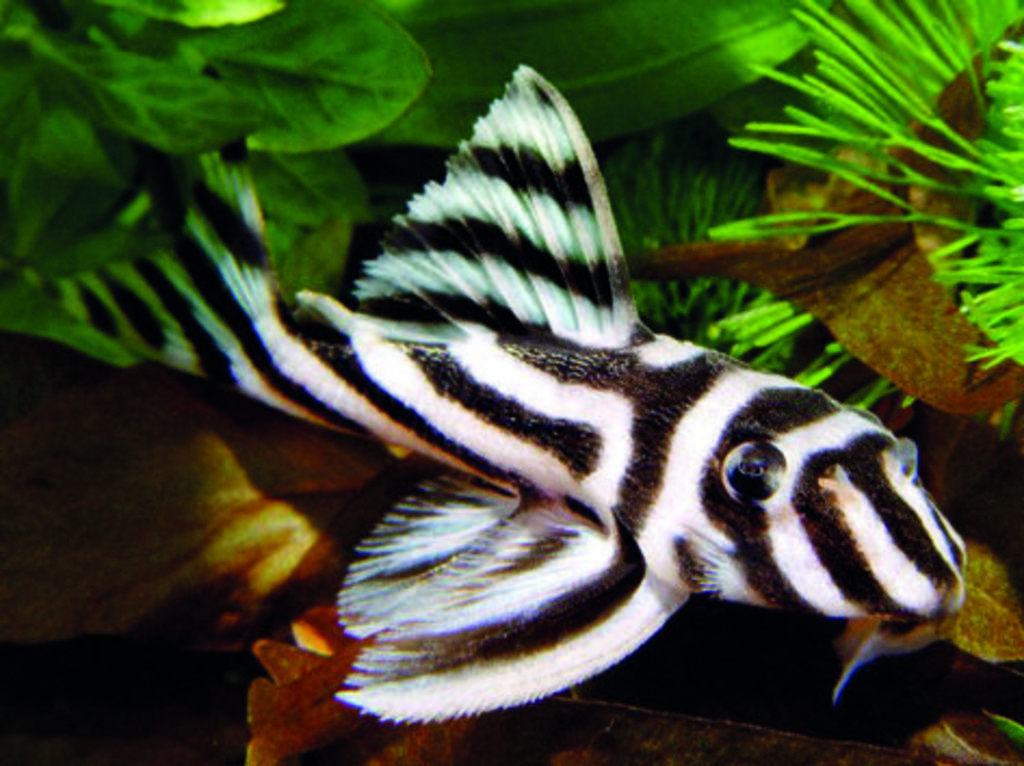In one or two sentences, can you explain what this image depicts? In this image there is a fish and few plants. 